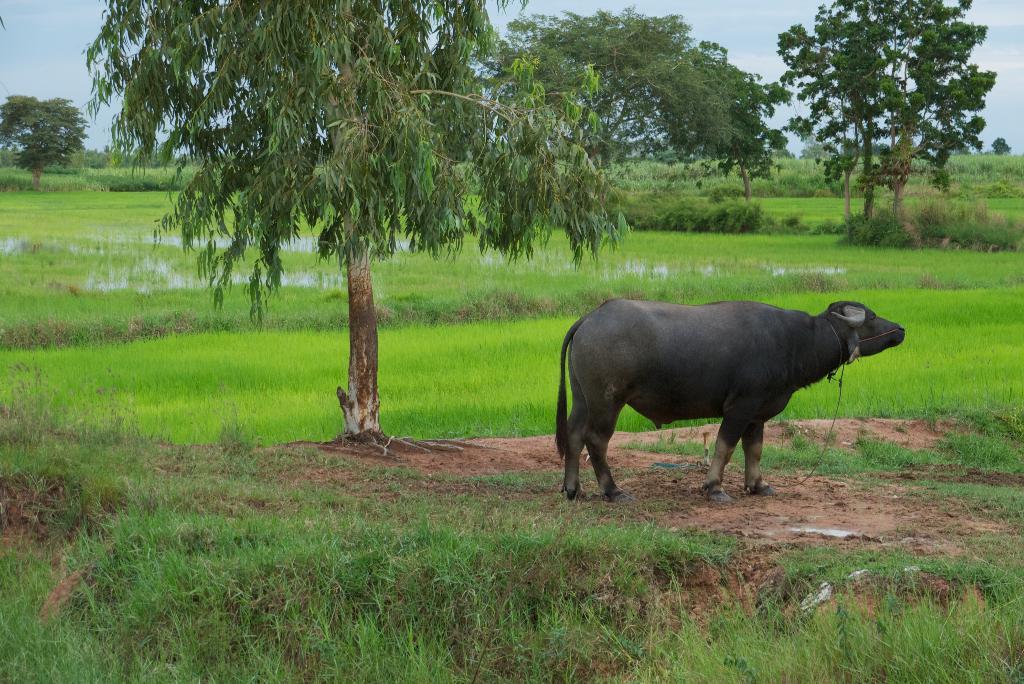Please provide a concise description of this image. In this image in the front there's grass on the ground. In the center there is an animal standing. In the background there are trees and there is water and the sky is cloudy and there is grass. 